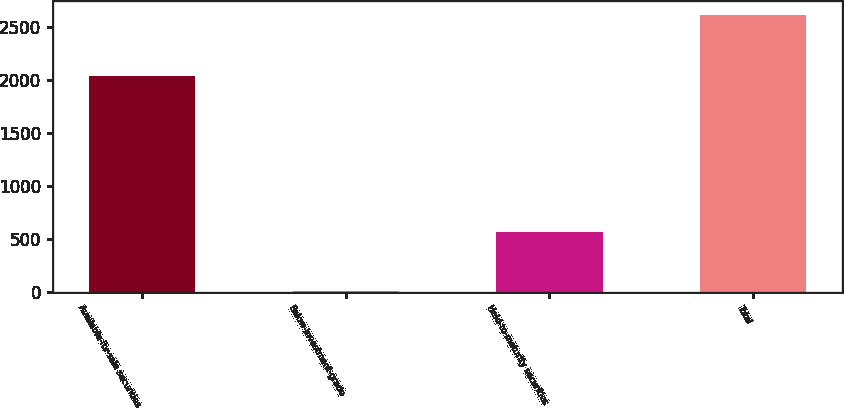Convert chart to OTSL. <chart><loc_0><loc_0><loc_500><loc_500><bar_chart><fcel>Available-for-sale securities<fcel>Below-investment-grade<fcel>Held-to-maturity securities<fcel>Total<nl><fcel>2038<fcel>6<fcel>571<fcel>2615<nl></chart> 